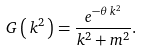Convert formula to latex. <formula><loc_0><loc_0><loc_500><loc_500>G \left ( \, k ^ { 2 } \, \right ) = \frac { e ^ { - \theta \, k ^ { 2 } } } { k ^ { 2 } + m ^ { 2 } } .</formula> 